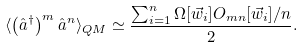<formula> <loc_0><loc_0><loc_500><loc_500>\langle \left ( \hat { a } ^ { \dagger } \right ) ^ { m } \hat { a } ^ { n } \rangle _ { Q M } \simeq \frac { \sum _ { i = 1 } ^ { n } \Omega [ \vec { w } _ { i } ] O _ { m n } [ \vec { w } _ { i } ] / n } { 2 } .</formula> 